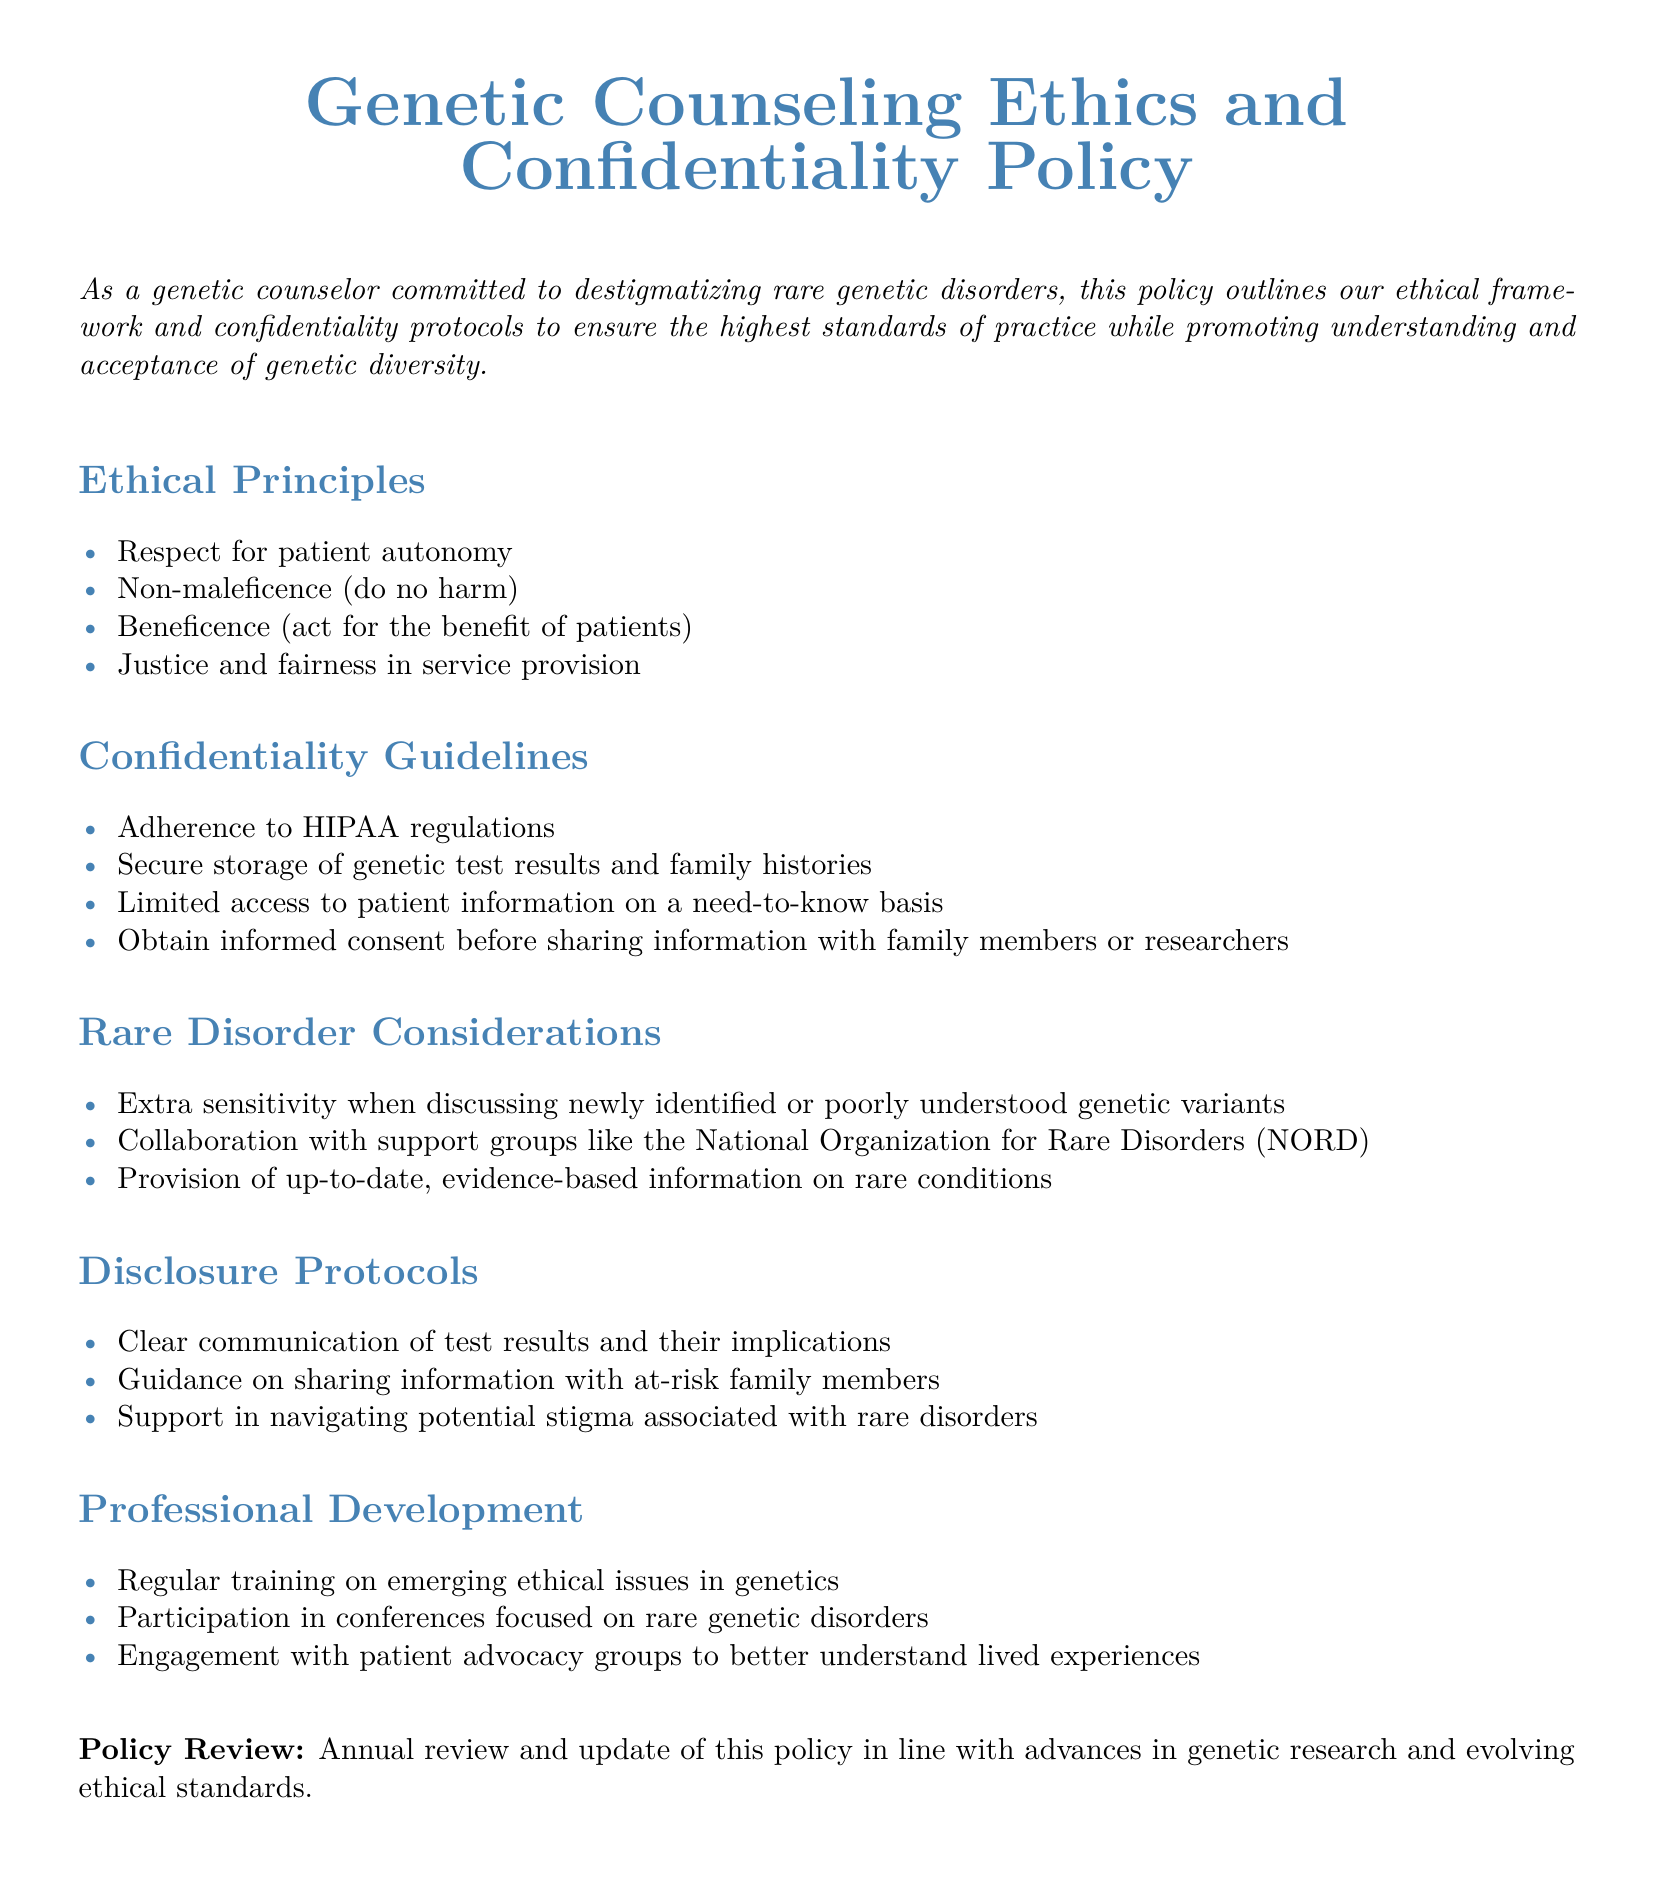What are the ethical principles outlined in the document? The ethical principles are mentioned in the Ethical Principles section, which includes respect for patient autonomy, non-maleficence, beneficence, and justice.
Answer: respect for patient autonomy, non-maleficence, beneficence, justice What is the main purpose of the confidentiality guidelines? The purpose is to ensure the secure handling of sensitive patient information, in line with regulations and ethical practices.
Answer: secure handling of sensitive patient information Which organization is mentioned for collaboration in handling rare disorders? The collaboration is specified in the Rare Disorder Considerations section, highlighting a specific support group involved in this work.
Answer: National Organization for Rare Disorders (NORD) How often will the policy be reviewed? This information is stated under the Policy Review section. The frequency of reviews is mentioned clearly.
Answer: Annual review What principle emphasizes "do no harm"? In the document, this principle is explicitly listed among the ethical principles, focusing on the counselor's duty toward patients.
Answer: Non-maleficence What is the focus of the regular training described in the document? The Professional Development section covers the focus of training, which is crucial for genetic counselors.
Answer: emerging ethical issues in genetics What type of information should be handled on a need-to-know basis? This relates to guidelines about access restrictions mentioned in the confidentiality guidelines section.
Answer: patient information What aspect does the disclosure protocol address for at-risk family members? The disclosure protocol provides guidance specifically to aid the communication of sensitive information to family members.
Answer: sharing information 